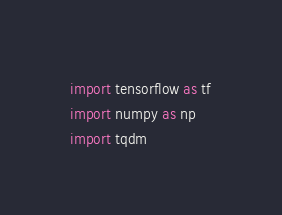Convert code to text. <code><loc_0><loc_0><loc_500><loc_500><_Python_>import tensorflow as tf
import numpy as np
import tqdm
</code> 